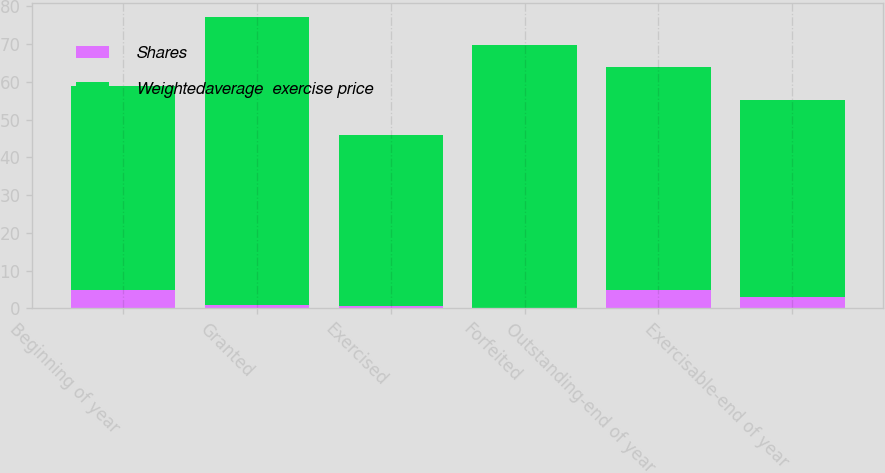Convert chart to OTSL. <chart><loc_0><loc_0><loc_500><loc_500><stacked_bar_chart><ecel><fcel>Beginning of year<fcel>Granted<fcel>Exercised<fcel>Forfeited<fcel>Outstanding-end of year<fcel>Exercisable-end of year<nl><fcel>Shares<fcel>4.8<fcel>0.8<fcel>0.7<fcel>0.1<fcel>4.8<fcel>3.1<nl><fcel>Weightedaverage  exercise price<fcel>54.17<fcel>76.32<fcel>45.22<fcel>69.67<fcel>59.2<fcel>51.99<nl></chart> 